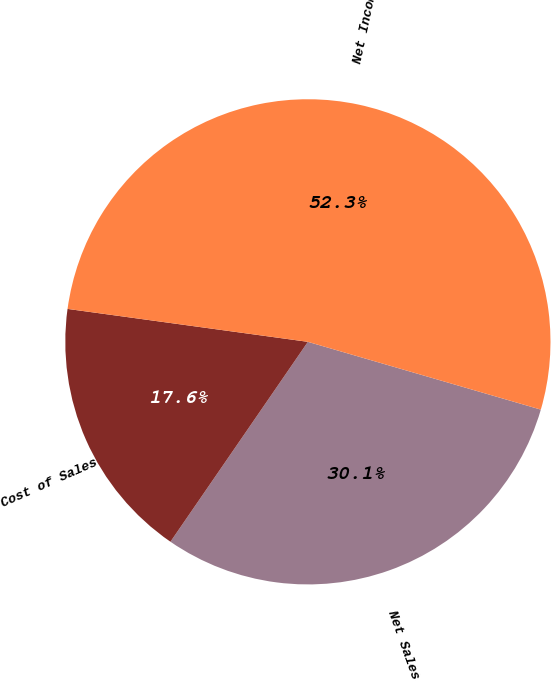<chart> <loc_0><loc_0><loc_500><loc_500><pie_chart><fcel>Net Sales<fcel>Cost of Sales<fcel>Net Income<nl><fcel>30.08%<fcel>17.58%<fcel>52.34%<nl></chart> 